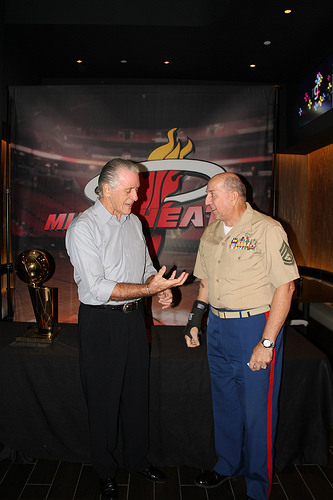<image>
Is the man behind the table? No. The man is not behind the table. From this viewpoint, the man appears to be positioned elsewhere in the scene. 